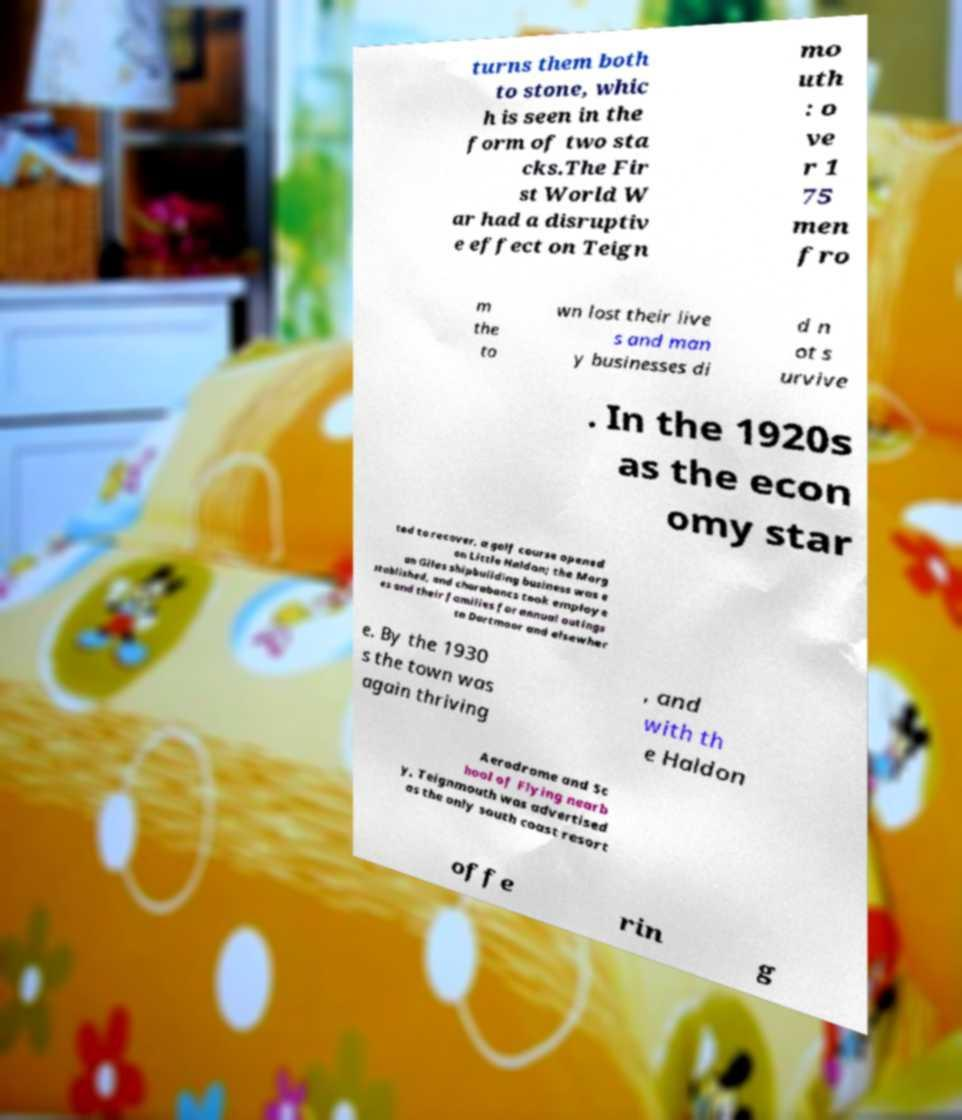For documentation purposes, I need the text within this image transcribed. Could you provide that? turns them both to stone, whic h is seen in the form of two sta cks.The Fir st World W ar had a disruptiv e effect on Teign mo uth : o ve r 1 75 men fro m the to wn lost their live s and man y businesses di d n ot s urvive . In the 1920s as the econ omy star ted to recover, a golf course opened on Little Haldon; the Morg an Giles shipbuilding business was e stablished, and charabancs took employe es and their families for annual outings to Dartmoor and elsewher e. By the 1930 s the town was again thriving , and with th e Haldon Aerodrome and Sc hool of Flying nearb y, Teignmouth was advertised as the only south coast resort offe rin g 